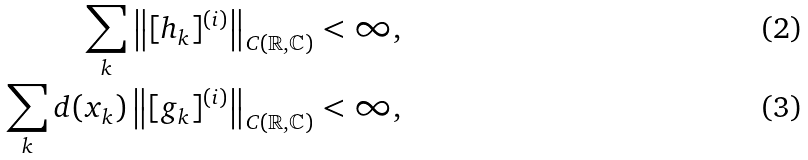<formula> <loc_0><loc_0><loc_500><loc_500>\sum _ { k } \left \| [ h _ { k } ] ^ { ( i ) } \right \| _ { C ( \mathbb { R } , \mathbb { C } ) } < \infty , \\ \sum _ { k } d ( x _ { k } ) \left \| [ g _ { k } ] ^ { ( i ) } \right \| _ { C ( \mathbb { R } , \mathbb { C } ) } < \infty ,</formula> 